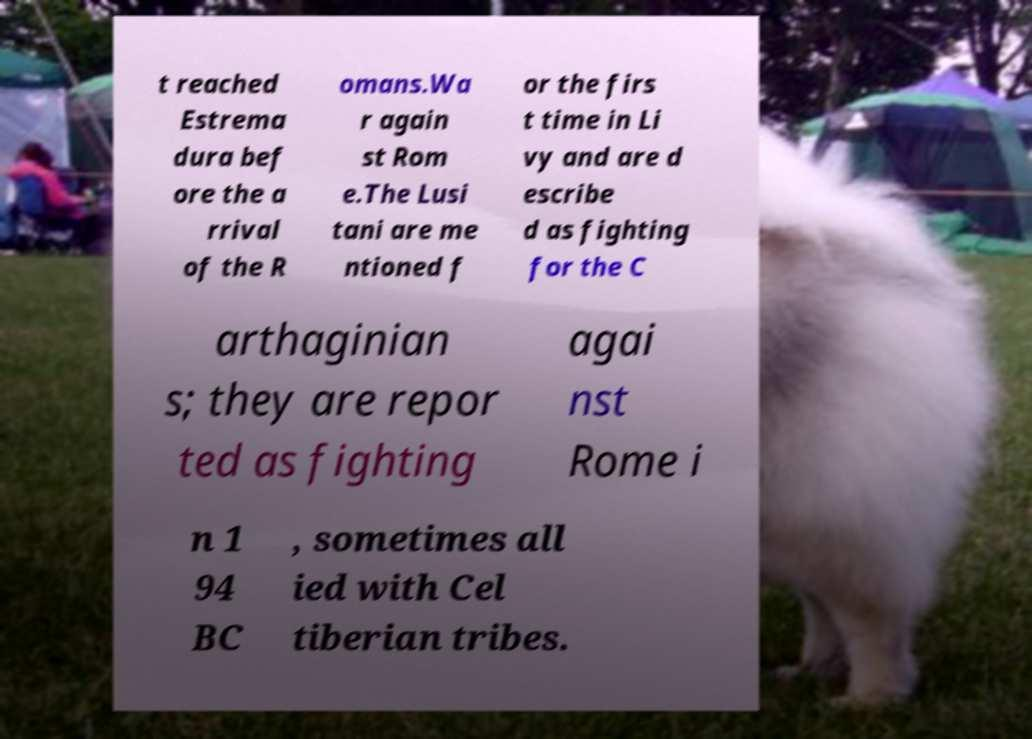There's text embedded in this image that I need extracted. Can you transcribe it verbatim? t reached Estrema dura bef ore the a rrival of the R omans.Wa r again st Rom e.The Lusi tani are me ntioned f or the firs t time in Li vy and are d escribe d as fighting for the C arthaginian s; they are repor ted as fighting agai nst Rome i n 1 94 BC , sometimes all ied with Cel tiberian tribes. 